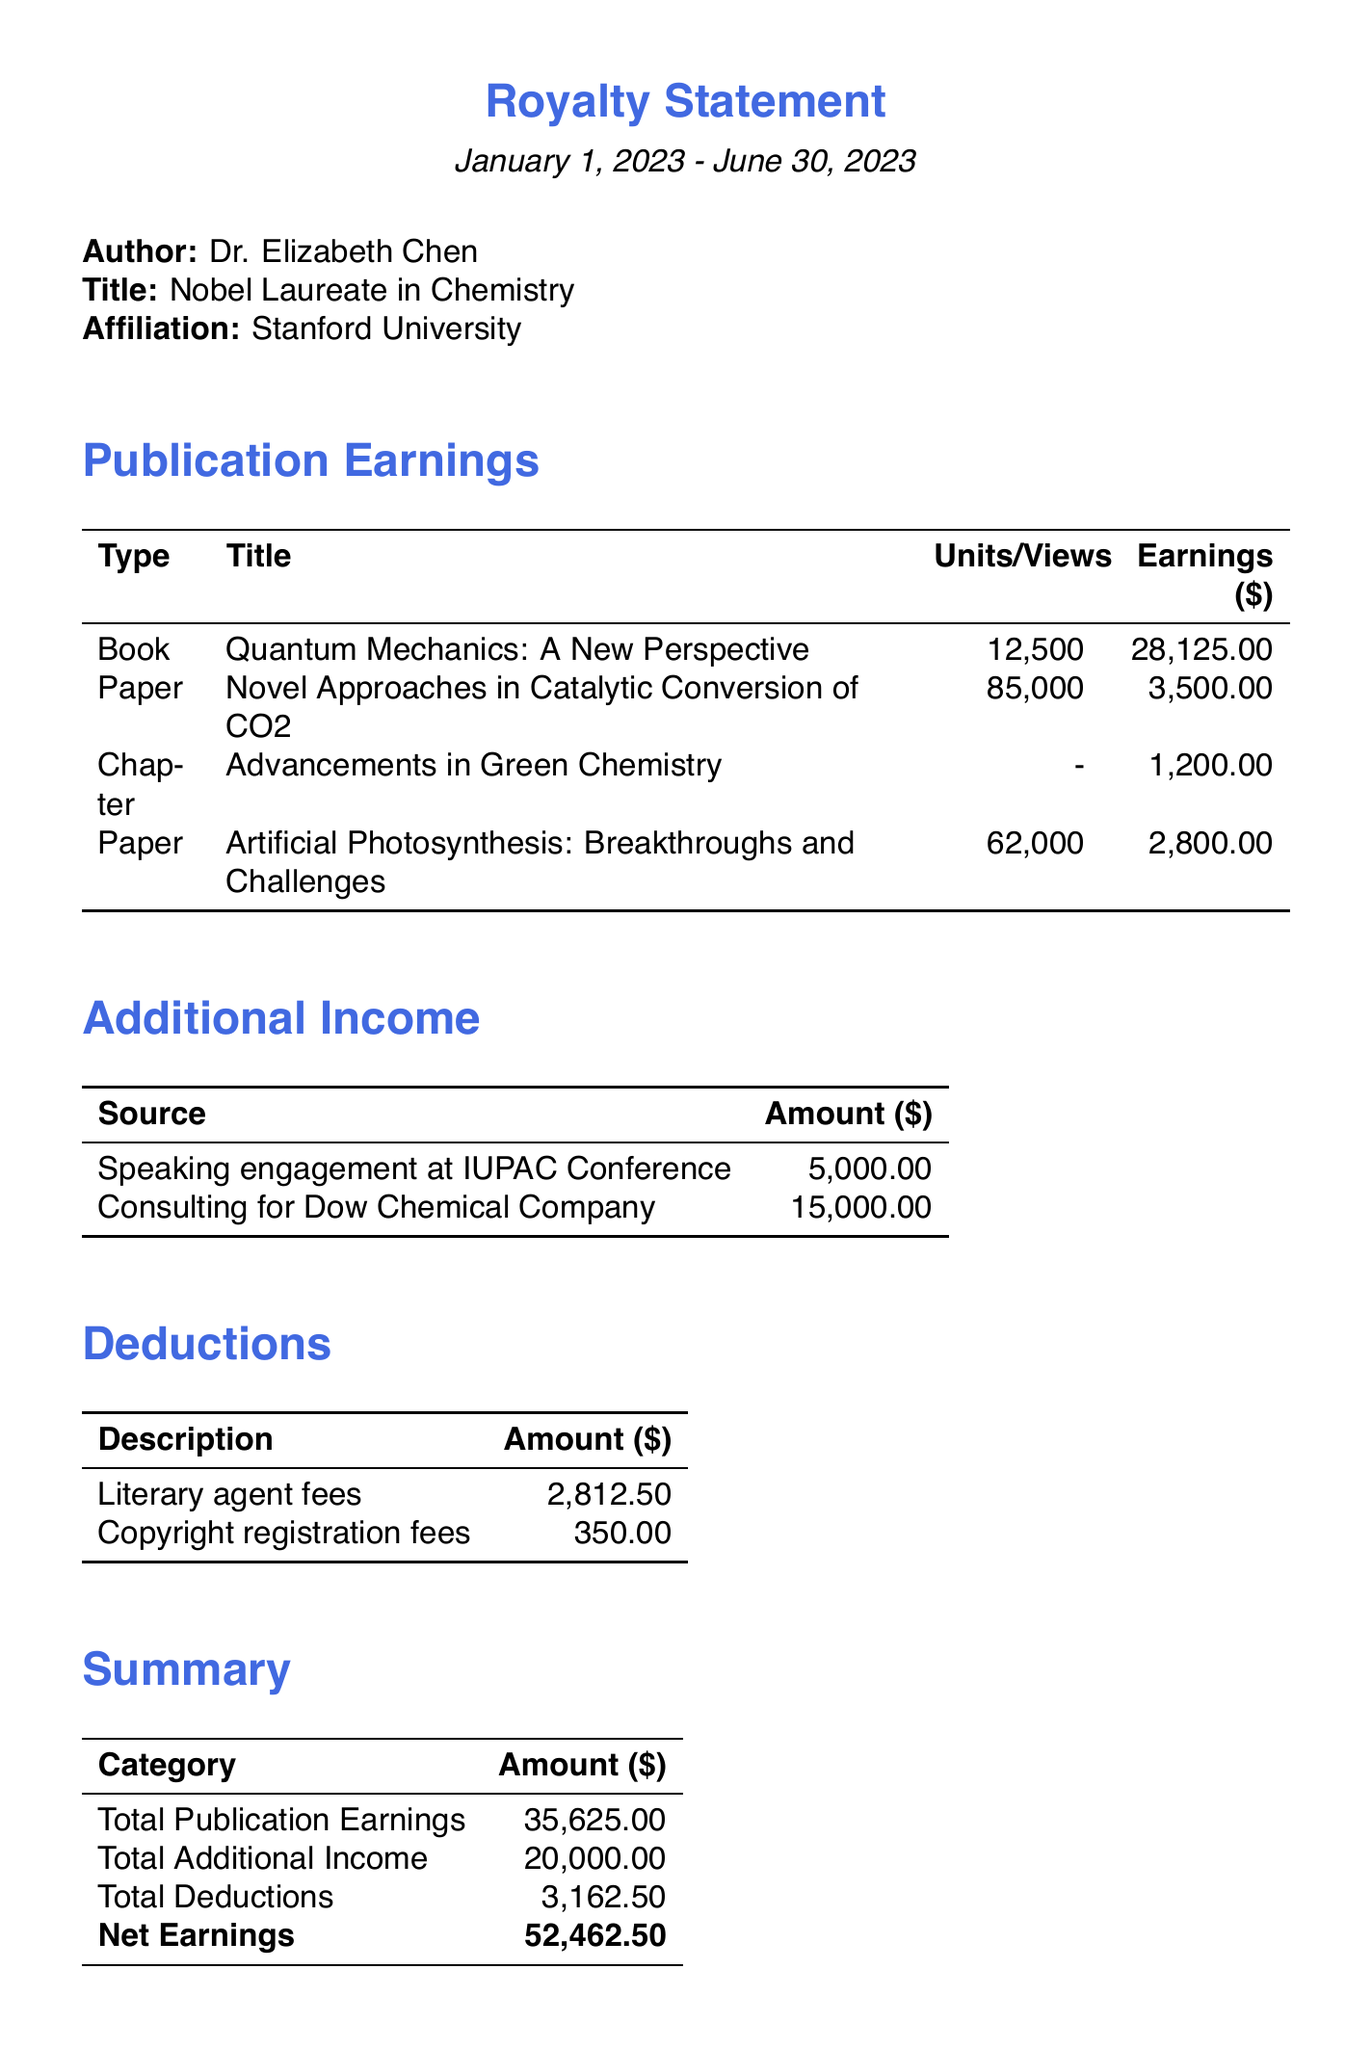What is the author's name? The author's name, as stated in the document, is Dr. Elizabeth Chen.
Answer: Dr. Elizabeth Chen What is the total earnings from publications? The total earnings from publications can be found in the summary section, totaling $35,625.00.
Answer: 35625.00 How many units of the book "Quantum Mechanics: A New Perspective" were sold? The number of units sold for the book is explicitly mentioned as 12,500.
Answer: 12,500 What is the net earnings reported in the document? The net earnings are a calculated value from the summary, which combines all earnings and deductions, amounting to $52,462.50.
Answer: 52462.50 What is one source of additional income? One source of additional income listed in the document is "Speaking engagement at IUPAC Conference."
Answer: Speaking engagement at IUPAC Conference What is the royalty rate for the book "Quantum Mechanics: A New Perspective"? The royalty rate can be found in the publication details for this book, which is 15%.
Answer: 0.15 What are the total deductions recorded? The total deductions figure can be found in the summary section of the document, which states it is $3,162.50.
Answer: 3162.50 Which bank is used for the payment method? The bank mentioned in the payment details for direct deposit is "Wells Fargo."
Answer: Wells Fargo How many scientific papers are listed in the document? The document mentions two scientific papers, as evidenced in the publications section.
Answer: 2 